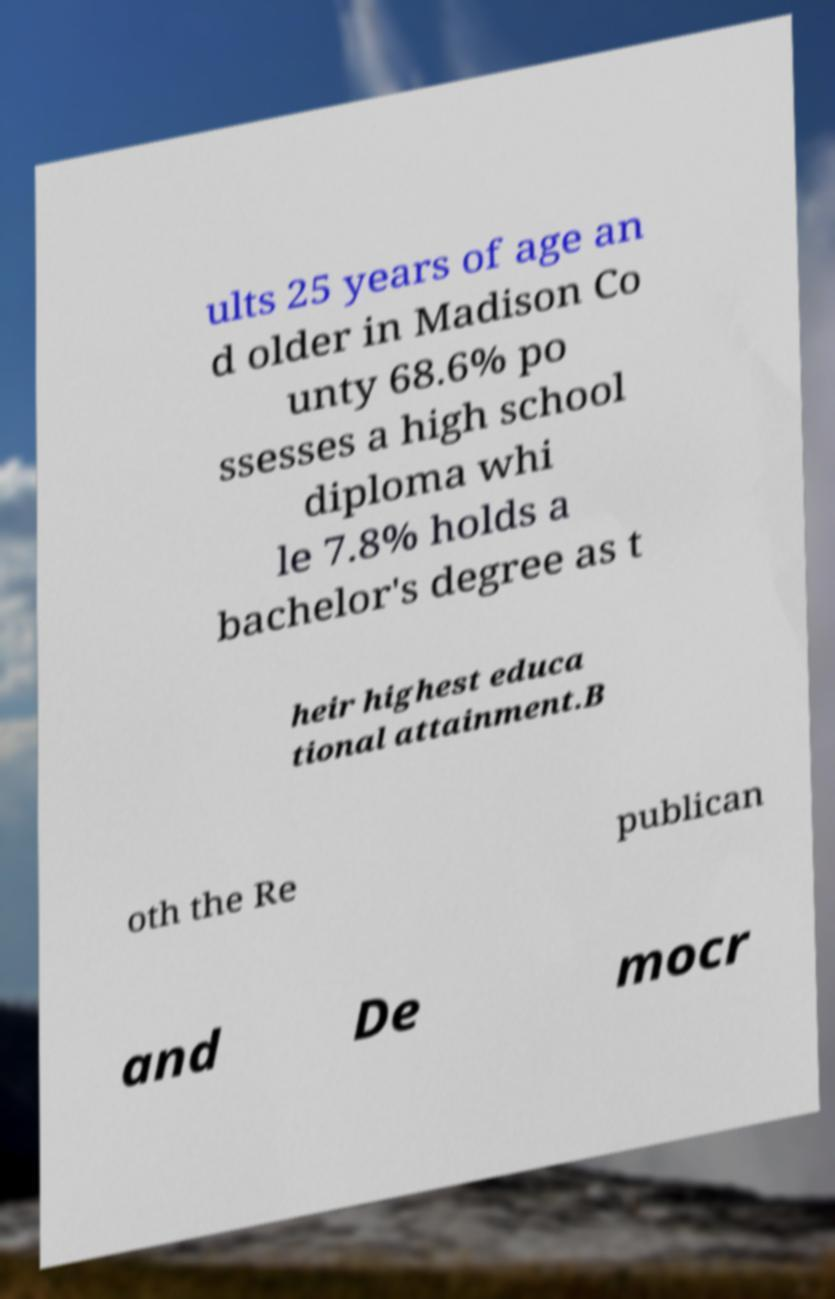What messages or text are displayed in this image? I need them in a readable, typed format. ults 25 years of age an d older in Madison Co unty 68.6% po ssesses a high school diploma whi le 7.8% holds a bachelor's degree as t heir highest educa tional attainment.B oth the Re publican and De mocr 